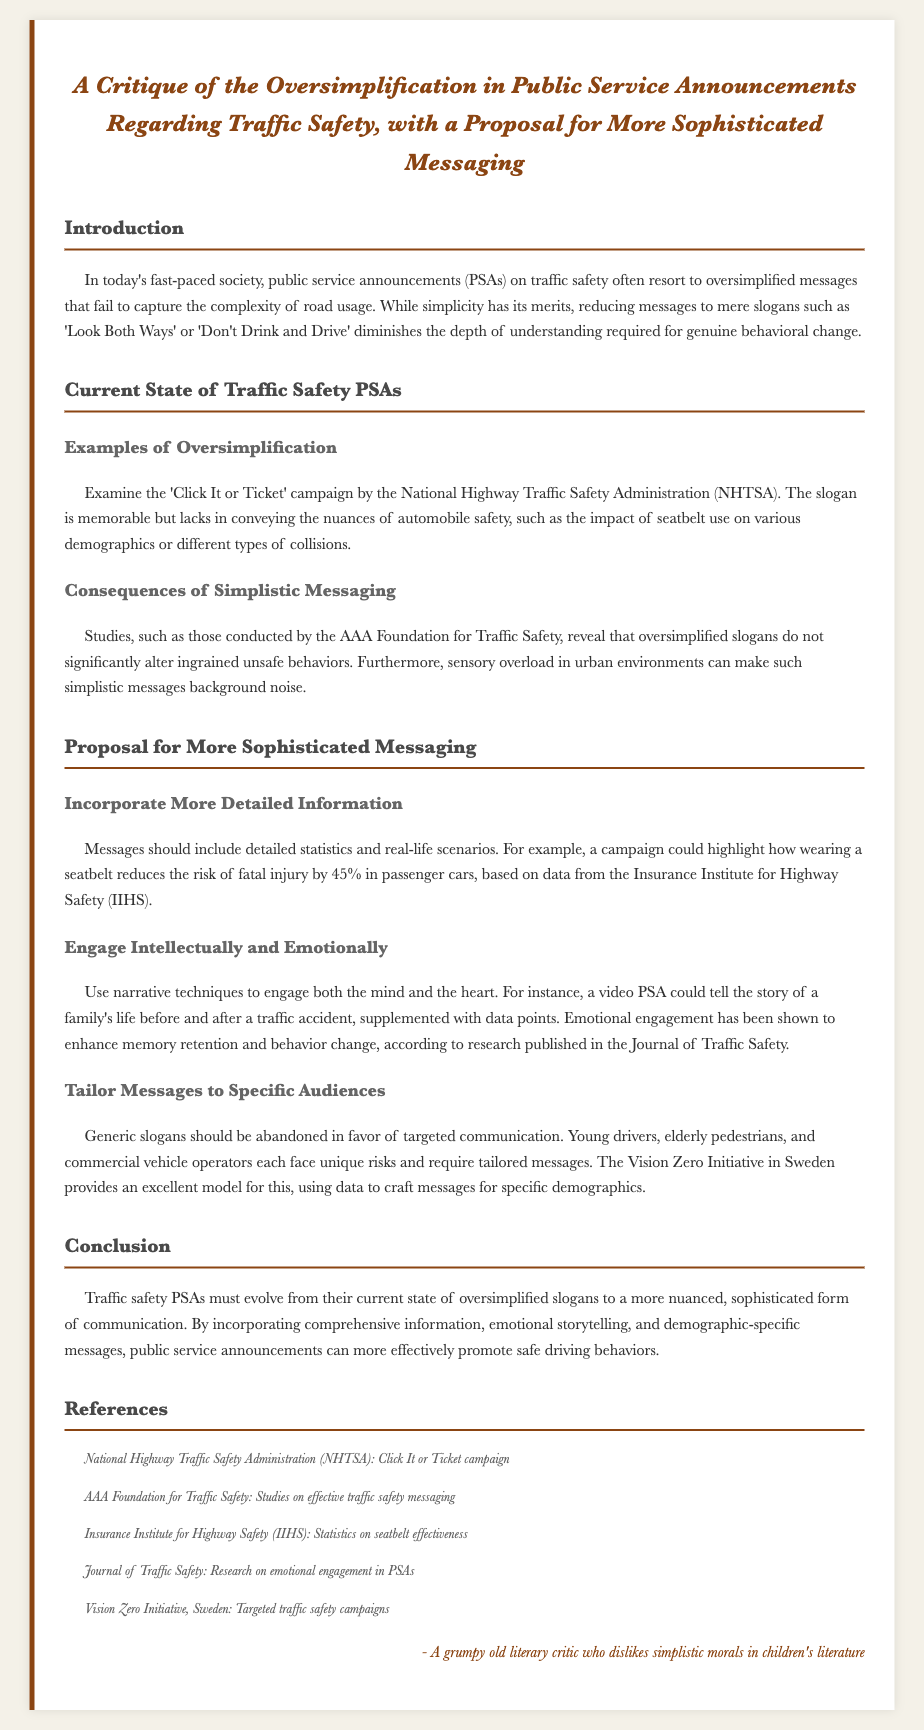what is the title of the document? The title is clearly stated at the top of the document.
Answer: A Critique of the Oversimplification in Public Service Announcements Regarding Traffic Safety, with a Proposal for More Sophisticated Messaging who conducted studies mentioned in the document? The studies referenced are conducted by a specific organization, which is noted in the text.
Answer: AAA Foundation for Traffic Safety what is one example of a current traffic safety PSA given in the document? The document provides a specific example of a campaign that exemplifies oversimplification in messaging.
Answer: Click It or Ticket by what percentage does wearing a seatbelt reduce the risk of fatal injury according to the document? The document cites a specific statistic from a recognized authority regarding seatbelt effectiveness.
Answer: 45% which initiative is mentioned as a model for targeted messaging? The document refers to an initiative that effectively tailors messages for traffic safety.
Answer: Vision Zero Initiative what is the main purpose of the proposed messaging framework? The document outlines a central goal for evolving the communication style used in PSAs.
Answer: Promote safe driving behaviors how should PSAs engage audiences according to the proposal? The document suggests a method of engagement that combines two different approaches for better impact.
Answer: Intellectually and Emotionally what is a consequence of oversimplified messaging mentioned in the document? The document discusses an effect that results from the lack of depth in PSAs.
Answer: Does not significantly alter ingrained unsafe behaviors 